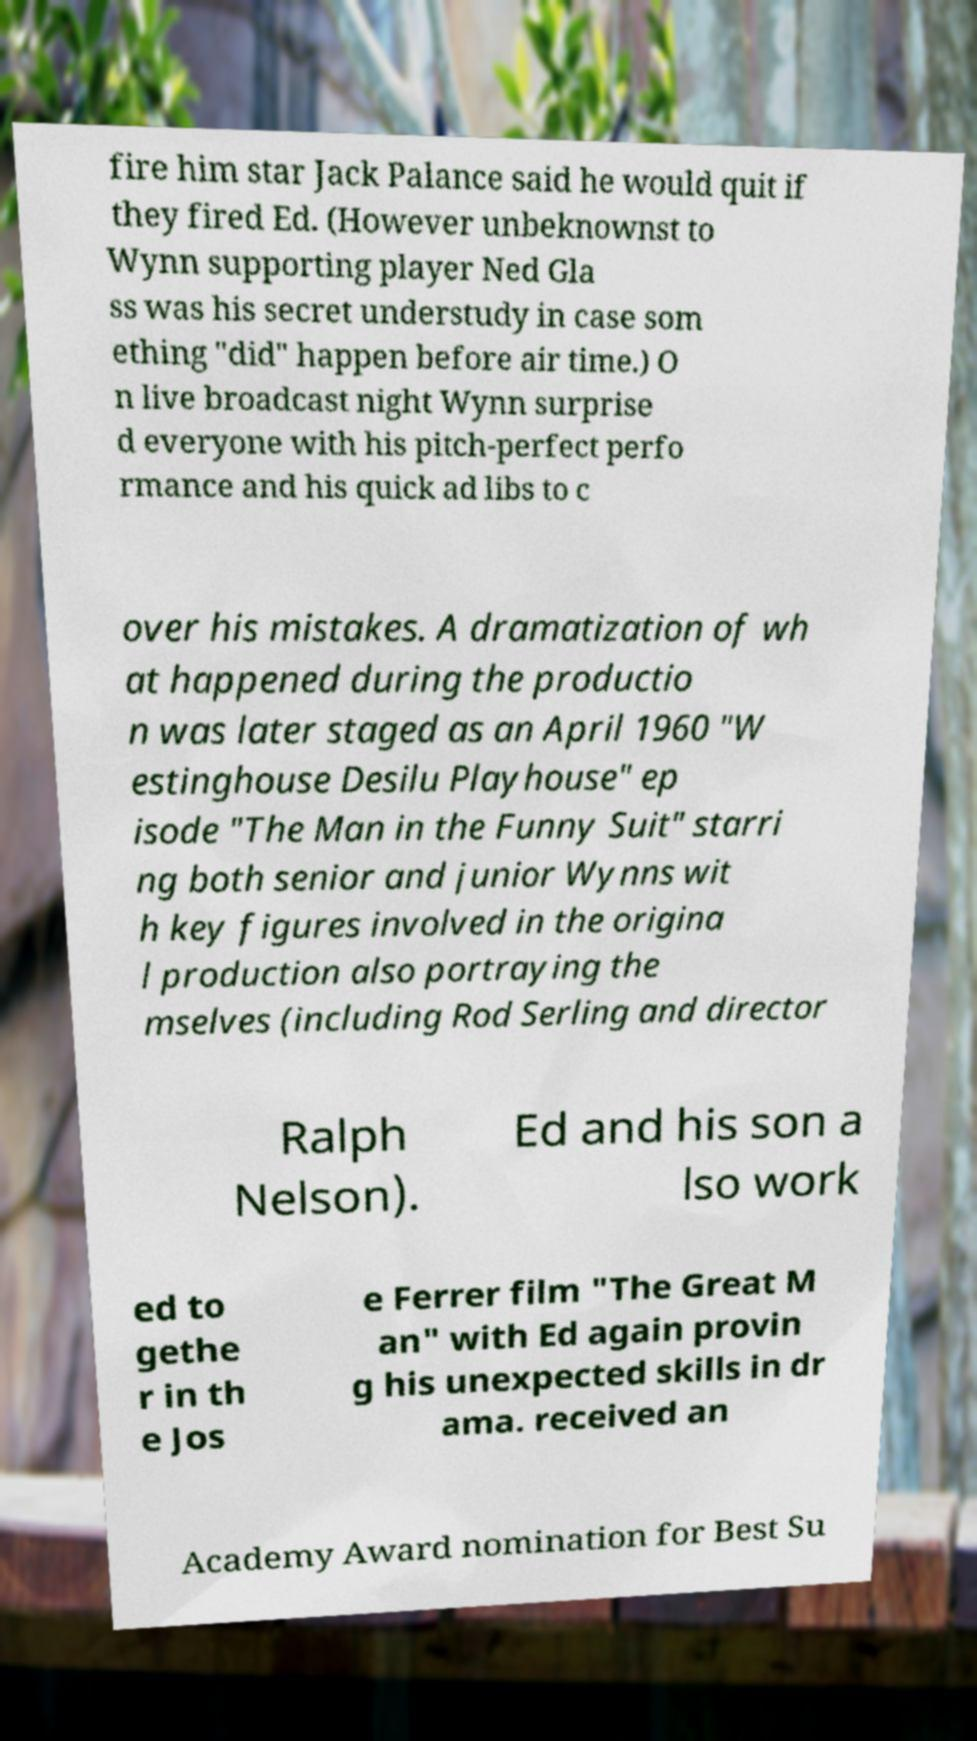What messages or text are displayed in this image? I need them in a readable, typed format. fire him star Jack Palance said he would quit if they fired Ed. (However unbeknownst to Wynn supporting player Ned Gla ss was his secret understudy in case som ething "did" happen before air time.) O n live broadcast night Wynn surprise d everyone with his pitch-perfect perfo rmance and his quick ad libs to c over his mistakes. A dramatization of wh at happened during the productio n was later staged as an April 1960 "W estinghouse Desilu Playhouse" ep isode "The Man in the Funny Suit" starri ng both senior and junior Wynns wit h key figures involved in the origina l production also portraying the mselves (including Rod Serling and director Ralph Nelson). Ed and his son a lso work ed to gethe r in th e Jos e Ferrer film "The Great M an" with Ed again provin g his unexpected skills in dr ama. received an Academy Award nomination for Best Su 